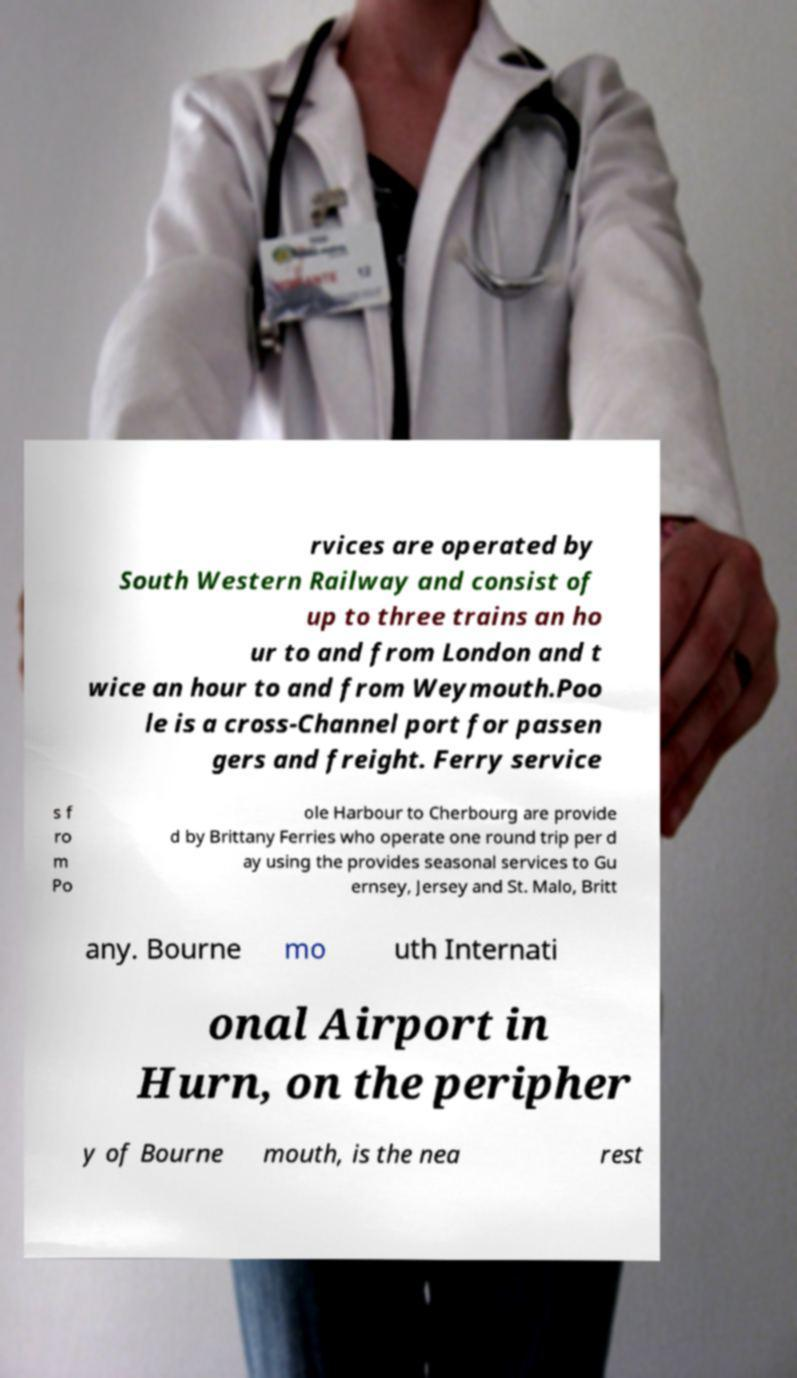Can you read and provide the text displayed in the image?This photo seems to have some interesting text. Can you extract and type it out for me? rvices are operated by South Western Railway and consist of up to three trains an ho ur to and from London and t wice an hour to and from Weymouth.Poo le is a cross-Channel port for passen gers and freight. Ferry service s f ro m Po ole Harbour to Cherbourg are provide d by Brittany Ferries who operate one round trip per d ay using the provides seasonal services to Gu ernsey, Jersey and St. Malo, Britt any. Bourne mo uth Internati onal Airport in Hurn, on the peripher y of Bourne mouth, is the nea rest 